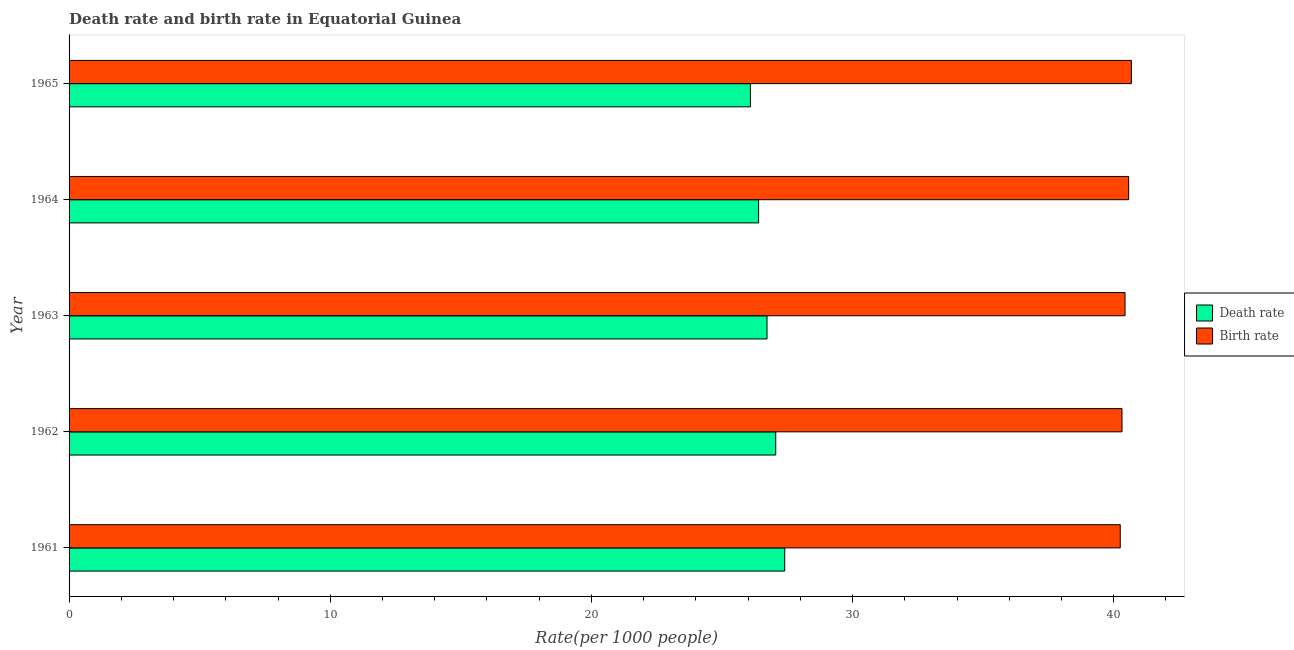How many different coloured bars are there?
Make the answer very short. 2. Are the number of bars on each tick of the Y-axis equal?
Your answer should be very brief. Yes. How many bars are there on the 2nd tick from the top?
Provide a short and direct response. 2. How many bars are there on the 1st tick from the bottom?
Provide a succinct answer. 2. What is the birth rate in 1962?
Offer a very short reply. 40.32. Across all years, what is the maximum death rate?
Give a very brief answer. 27.4. Across all years, what is the minimum death rate?
Provide a succinct answer. 26.09. In which year was the birth rate maximum?
Your answer should be very brief. 1965. What is the total death rate in the graph?
Make the answer very short. 133.68. What is the difference between the death rate in 1962 and that in 1964?
Offer a very short reply. 0.66. What is the difference between the death rate in 1961 and the birth rate in 1965?
Your answer should be very brief. -13.27. What is the average birth rate per year?
Keep it short and to the point. 40.45. In the year 1965, what is the difference between the birth rate and death rate?
Provide a short and direct response. 14.59. In how many years, is the death rate greater than 22 ?
Provide a short and direct response. 5. What is the ratio of the death rate in 1964 to that in 1965?
Your answer should be compact. 1.01. Is the death rate in 1963 less than that in 1965?
Your answer should be compact. No. What is the difference between the highest and the second highest birth rate?
Give a very brief answer. 0.1. What is the difference between the highest and the lowest birth rate?
Give a very brief answer. 0.43. In how many years, is the birth rate greater than the average birth rate taken over all years?
Offer a very short reply. 2. What does the 2nd bar from the top in 1961 represents?
Make the answer very short. Death rate. What does the 1st bar from the bottom in 1962 represents?
Your answer should be very brief. Death rate. Are all the bars in the graph horizontal?
Make the answer very short. Yes. How many years are there in the graph?
Provide a short and direct response. 5. Are the values on the major ticks of X-axis written in scientific E-notation?
Your answer should be compact. No. Does the graph contain grids?
Provide a short and direct response. No. How many legend labels are there?
Provide a short and direct response. 2. What is the title of the graph?
Keep it short and to the point. Death rate and birth rate in Equatorial Guinea. Does "UN agencies" appear as one of the legend labels in the graph?
Your answer should be compact. No. What is the label or title of the X-axis?
Give a very brief answer. Rate(per 1000 people). What is the Rate(per 1000 people) of Death rate in 1961?
Offer a very short reply. 27.4. What is the Rate(per 1000 people) of Birth rate in 1961?
Keep it short and to the point. 40.25. What is the Rate(per 1000 people) in Death rate in 1962?
Provide a succinct answer. 27.06. What is the Rate(per 1000 people) of Birth rate in 1962?
Offer a terse response. 40.32. What is the Rate(per 1000 people) of Death rate in 1963?
Provide a succinct answer. 26.73. What is the Rate(per 1000 people) of Birth rate in 1963?
Keep it short and to the point. 40.43. What is the Rate(per 1000 people) in Death rate in 1964?
Provide a succinct answer. 26.4. What is the Rate(per 1000 people) of Birth rate in 1964?
Your answer should be very brief. 40.57. What is the Rate(per 1000 people) in Death rate in 1965?
Your answer should be very brief. 26.09. What is the Rate(per 1000 people) in Birth rate in 1965?
Ensure brevity in your answer.  40.68. Across all years, what is the maximum Rate(per 1000 people) of Death rate?
Offer a very short reply. 27.4. Across all years, what is the maximum Rate(per 1000 people) of Birth rate?
Keep it short and to the point. 40.68. Across all years, what is the minimum Rate(per 1000 people) of Death rate?
Offer a terse response. 26.09. Across all years, what is the minimum Rate(per 1000 people) in Birth rate?
Provide a short and direct response. 40.25. What is the total Rate(per 1000 people) of Death rate in the graph?
Ensure brevity in your answer.  133.68. What is the total Rate(per 1000 people) of Birth rate in the graph?
Your response must be concise. 202.25. What is the difference between the Rate(per 1000 people) of Death rate in 1961 and that in 1962?
Provide a succinct answer. 0.34. What is the difference between the Rate(per 1000 people) in Birth rate in 1961 and that in 1962?
Your response must be concise. -0.07. What is the difference between the Rate(per 1000 people) in Death rate in 1961 and that in 1963?
Offer a terse response. 0.68. What is the difference between the Rate(per 1000 people) of Birth rate in 1961 and that in 1963?
Offer a terse response. -0.18. What is the difference between the Rate(per 1000 people) of Death rate in 1961 and that in 1964?
Provide a short and direct response. 1. What is the difference between the Rate(per 1000 people) of Birth rate in 1961 and that in 1964?
Provide a succinct answer. -0.32. What is the difference between the Rate(per 1000 people) of Death rate in 1961 and that in 1965?
Your answer should be very brief. 1.31. What is the difference between the Rate(per 1000 people) in Birth rate in 1961 and that in 1965?
Make the answer very short. -0.43. What is the difference between the Rate(per 1000 people) in Death rate in 1962 and that in 1963?
Provide a succinct answer. 0.33. What is the difference between the Rate(per 1000 people) of Birth rate in 1962 and that in 1963?
Provide a succinct answer. -0.12. What is the difference between the Rate(per 1000 people) in Death rate in 1962 and that in 1964?
Make the answer very short. 0.66. What is the difference between the Rate(per 1000 people) of Birth rate in 1962 and that in 1964?
Give a very brief answer. -0.26. What is the difference between the Rate(per 1000 people) of Death rate in 1962 and that in 1965?
Provide a succinct answer. 0.97. What is the difference between the Rate(per 1000 people) of Birth rate in 1962 and that in 1965?
Your response must be concise. -0.36. What is the difference between the Rate(per 1000 people) in Death rate in 1963 and that in 1964?
Your answer should be very brief. 0.32. What is the difference between the Rate(per 1000 people) of Birth rate in 1963 and that in 1964?
Offer a very short reply. -0.14. What is the difference between the Rate(per 1000 people) of Death rate in 1963 and that in 1965?
Offer a terse response. 0.64. What is the difference between the Rate(per 1000 people) of Birth rate in 1963 and that in 1965?
Your response must be concise. -0.24. What is the difference between the Rate(per 1000 people) of Death rate in 1964 and that in 1965?
Ensure brevity in your answer.  0.31. What is the difference between the Rate(per 1000 people) of Birth rate in 1964 and that in 1965?
Your answer should be very brief. -0.1. What is the difference between the Rate(per 1000 people) in Death rate in 1961 and the Rate(per 1000 people) in Birth rate in 1962?
Ensure brevity in your answer.  -12.91. What is the difference between the Rate(per 1000 people) of Death rate in 1961 and the Rate(per 1000 people) of Birth rate in 1963?
Give a very brief answer. -13.03. What is the difference between the Rate(per 1000 people) in Death rate in 1961 and the Rate(per 1000 people) in Birth rate in 1964?
Ensure brevity in your answer.  -13.17. What is the difference between the Rate(per 1000 people) in Death rate in 1961 and the Rate(per 1000 people) in Birth rate in 1965?
Your response must be concise. -13.28. What is the difference between the Rate(per 1000 people) of Death rate in 1962 and the Rate(per 1000 people) of Birth rate in 1963?
Provide a short and direct response. -13.38. What is the difference between the Rate(per 1000 people) of Death rate in 1962 and the Rate(per 1000 people) of Birth rate in 1964?
Your answer should be very brief. -13.51. What is the difference between the Rate(per 1000 people) in Death rate in 1962 and the Rate(per 1000 people) in Birth rate in 1965?
Ensure brevity in your answer.  -13.62. What is the difference between the Rate(per 1000 people) of Death rate in 1963 and the Rate(per 1000 people) of Birth rate in 1964?
Your answer should be compact. -13.85. What is the difference between the Rate(per 1000 people) of Death rate in 1963 and the Rate(per 1000 people) of Birth rate in 1965?
Your answer should be very brief. -13.95. What is the difference between the Rate(per 1000 people) in Death rate in 1964 and the Rate(per 1000 people) in Birth rate in 1965?
Offer a very short reply. -14.28. What is the average Rate(per 1000 people) of Death rate per year?
Offer a very short reply. 26.74. What is the average Rate(per 1000 people) in Birth rate per year?
Offer a very short reply. 40.45. In the year 1961, what is the difference between the Rate(per 1000 people) in Death rate and Rate(per 1000 people) in Birth rate?
Provide a short and direct response. -12.85. In the year 1962, what is the difference between the Rate(per 1000 people) in Death rate and Rate(per 1000 people) in Birth rate?
Your answer should be compact. -13.26. In the year 1963, what is the difference between the Rate(per 1000 people) of Death rate and Rate(per 1000 people) of Birth rate?
Make the answer very short. -13.71. In the year 1964, what is the difference between the Rate(per 1000 people) in Death rate and Rate(per 1000 people) in Birth rate?
Your response must be concise. -14.17. In the year 1965, what is the difference between the Rate(per 1000 people) of Death rate and Rate(per 1000 people) of Birth rate?
Provide a short and direct response. -14.59. What is the ratio of the Rate(per 1000 people) of Death rate in 1961 to that in 1962?
Keep it short and to the point. 1.01. What is the ratio of the Rate(per 1000 people) of Birth rate in 1961 to that in 1962?
Keep it short and to the point. 1. What is the ratio of the Rate(per 1000 people) in Death rate in 1961 to that in 1963?
Provide a succinct answer. 1.03. What is the ratio of the Rate(per 1000 people) of Death rate in 1961 to that in 1964?
Keep it short and to the point. 1.04. What is the ratio of the Rate(per 1000 people) of Birth rate in 1961 to that in 1964?
Provide a succinct answer. 0.99. What is the ratio of the Rate(per 1000 people) in Death rate in 1961 to that in 1965?
Your answer should be compact. 1.05. What is the ratio of the Rate(per 1000 people) of Death rate in 1962 to that in 1963?
Provide a succinct answer. 1.01. What is the ratio of the Rate(per 1000 people) in Death rate in 1962 to that in 1964?
Provide a succinct answer. 1.02. What is the ratio of the Rate(per 1000 people) in Death rate in 1962 to that in 1965?
Your answer should be very brief. 1.04. What is the ratio of the Rate(per 1000 people) of Death rate in 1963 to that in 1964?
Your response must be concise. 1.01. What is the ratio of the Rate(per 1000 people) in Death rate in 1963 to that in 1965?
Give a very brief answer. 1.02. What is the ratio of the Rate(per 1000 people) in Death rate in 1964 to that in 1965?
Make the answer very short. 1.01. What is the difference between the highest and the second highest Rate(per 1000 people) of Death rate?
Provide a succinct answer. 0.34. What is the difference between the highest and the second highest Rate(per 1000 people) in Birth rate?
Your answer should be compact. 0.1. What is the difference between the highest and the lowest Rate(per 1000 people) of Death rate?
Give a very brief answer. 1.31. What is the difference between the highest and the lowest Rate(per 1000 people) of Birth rate?
Your response must be concise. 0.43. 